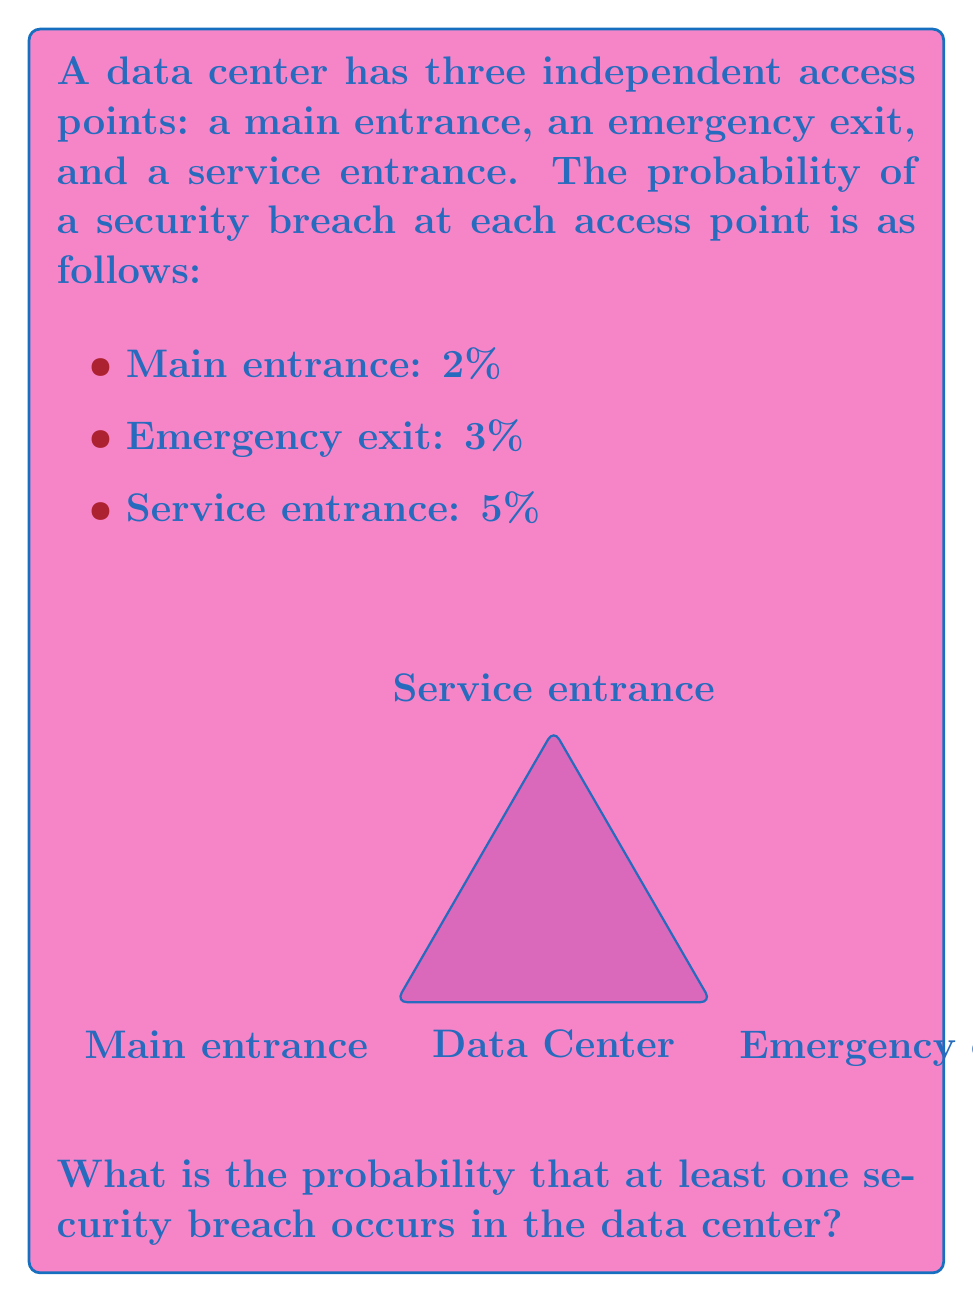Could you help me with this problem? To solve this problem, we'll use the concept of probability of independent events and the complement rule.

Step 1: Calculate the probability that no breach occurs at each access point.
- Main entrance: $P(\text{no breach}) = 1 - 0.02 = 0.98$
- Emergency exit: $P(\text{no breach}) = 1 - 0.03 = 0.97$
- Service entrance: $P(\text{no breach}) = 1 - 0.05 = 0.95$

Step 2: Calculate the probability that no breach occurs at any access point.
Since the events are independent, we multiply the individual probabilities:

$$P(\text{no breach anywhere}) = 0.98 \times 0.97 \times 0.95 = 0.9028$$

Step 3: Use the complement rule to find the probability of at least one breach.
The probability of at least one breach is the complement of the probability of no breach:

$$P(\text{at least one breach}) = 1 - P(\text{no breach anywhere})$$
$$P(\text{at least one breach}) = 1 - 0.9028 = 0.0972$$

Step 4: Convert to a percentage.
$$0.0972 \times 100\% = 9.72\%$$

Therefore, the probability of at least one security breach occurring in the data center is 9.72%.
Answer: 9.72% 